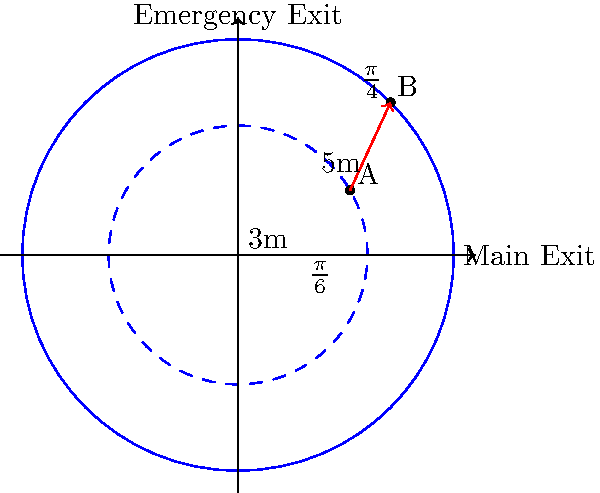In a circular school building, an evacuation route is planned from point A $(3, \frac{\pi}{6})$ to point B $(5, \frac{\pi}{4})$ in polar coordinates (r, θ). Calculate the length of this evacuation route to the nearest tenth of a meter. To find the length of the evacuation route, we need to use the distance formula in polar coordinates:

1) The distance formula between two points $(r_1, \theta_1)$ and $(r_2, \theta_2)$ in polar coordinates is:

   $$d = \sqrt{r_1^2 + r_2^2 - 2r_1r_2 \cos(\theta_2 - \theta_1)}$$

2) In this case:
   $r_1 = 3$, $\theta_1 = \frac{\pi}{6}$
   $r_2 = 5$, $\theta_2 = \frac{\pi}{4}$

3) Substituting these values:

   $$d = \sqrt{3^2 + 5^2 - 2(3)(5) \cos(\frac{\pi}{4} - \frac{\pi}{6})}$$

4) Simplify inside the cosine:
   $$\frac{\pi}{4} - \frac{\pi}{6} = \frac{\pi}{12}$$

5) Calculate:
   $$d = \sqrt{9 + 25 - 30 \cos(\frac{\pi}{12})}$$
   $$d = \sqrt{34 - 30 \cos(\frac{\pi}{12})}$$

6) Using a calculator:
   $$d \approx 2.236$$

7) Rounding to the nearest tenth:
   $$d \approx 2.2 \text{ meters}$$
Answer: 2.2 meters 